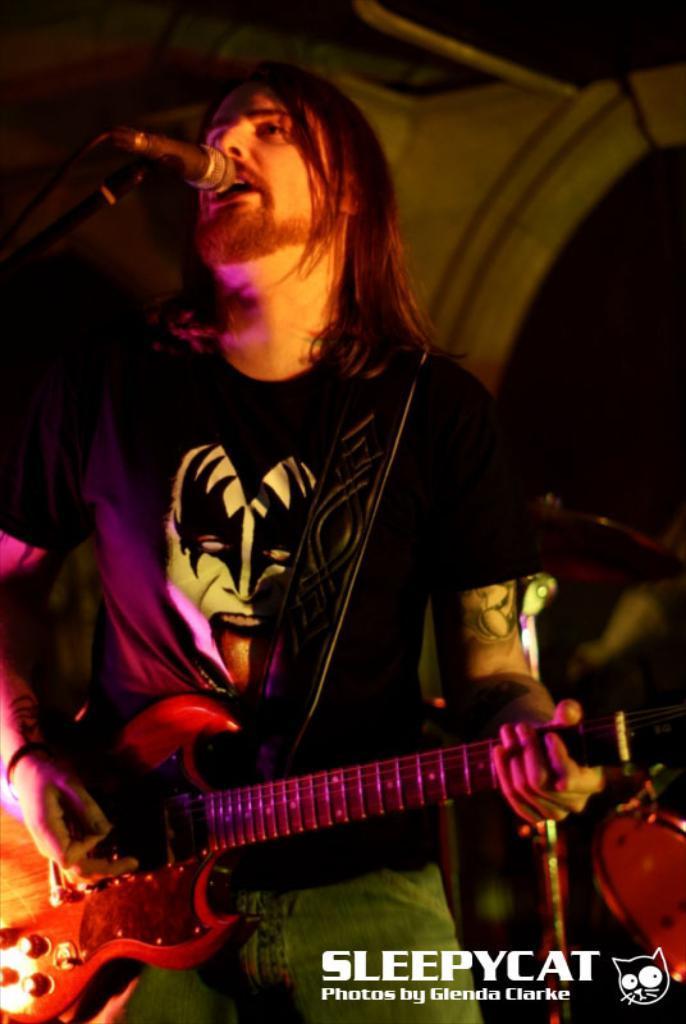How would you summarize this image in a sentence or two? In this image we can see a man playing guitar and singing through the mic in front of him. 